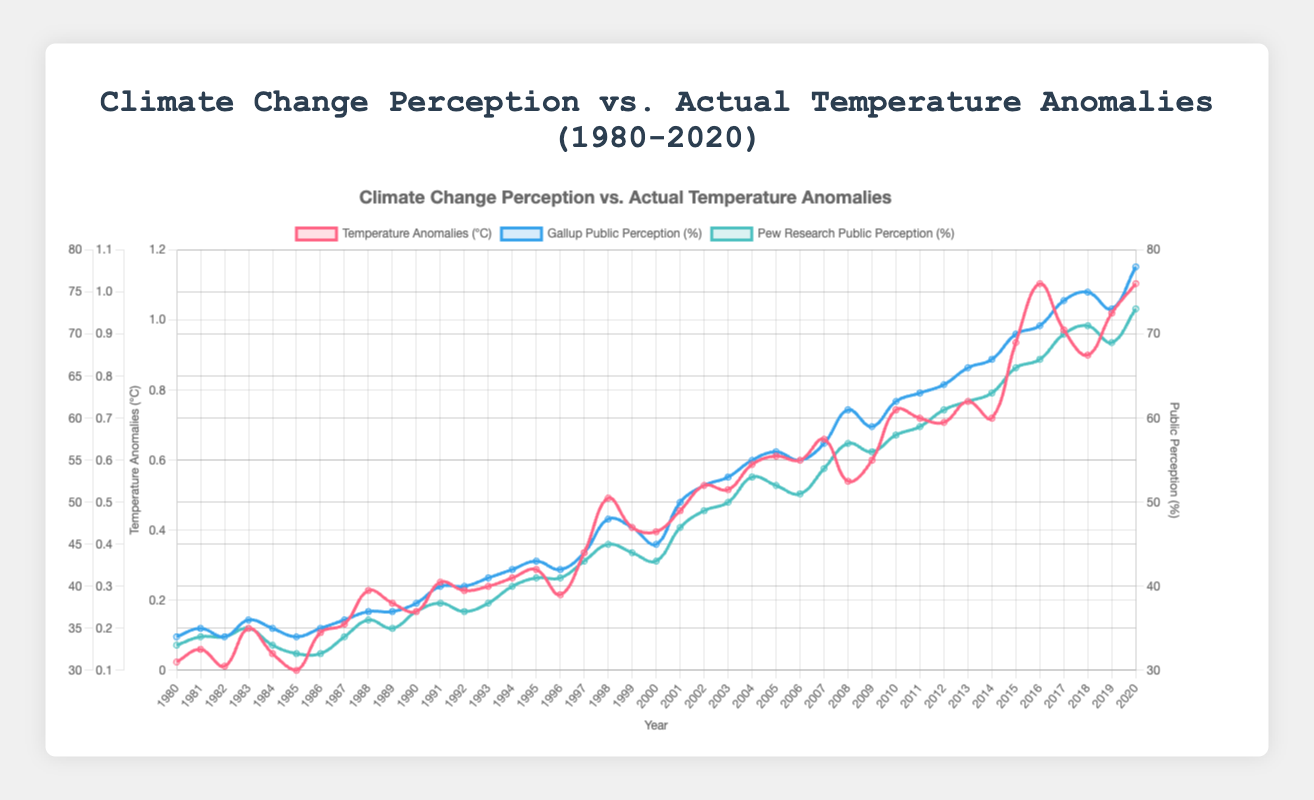Which survey had the higher perception of climate change in 2015? Look at the data points for Gallup and Pew Research in 2015 and compare their values. Gallup has 67%, while Pew Research has 63%.
Answer: Gallup What is the average temperature anomaly for the years 2000 to 2010? Sum the temperature anomaly values from 2000 to 2010 and divide by the number of years. The sum is (0.43 + 0.48 + 0.54 + 0.53 + 0.59 + 0.61 + 0.60 + 0.65 + 0.55 + 0.60 + 0.72), which equals 6.00. Divide by 11 to get the average, 6.00 / 11 = 0.545.
Answer: 0.545 In which year do both Gallup and Pew Research show the same perception percentage? Identify the year where Gallup and Pew Research lines intersect or have the same value. In 1982, both Gallup and Pew Research have a perception value of 34%.
Answer: 1982 By how much did the temperature anomaly change from 1980 to 2020? Find the difference between the temperature anomaly in 2020 and 1980. In 2020, the value is 1.02, and in 1980, it is 0.12. The change is 1.02 - 0.12 = 0.90.
Answer: 0.90 Which year had the highest temperature anomaly? To identify the highest point on the temperature anomaly line, find the year corresponding to the peak value. The highest value is 1.02, occurring in 2016 and 2020.
Answer: 2016 and 2020 What was the Pew Research public perception percentage in 2009, and how did it compare to Gallup for the same year? Look at the Pew Research value for 2009, which is 56%, and compare it to Gallup's value for 2009, which is also 59%.
Answer: Pew Research: 56%, Gallup: 59% How many times did the Gallup public perception of climate change surpass 60%? Count the number of years where the Gallup perception value is greater than 60%. This occurs in 2007, 2010-2020.
Answer: 11 times What is the total increase in Gallup public perception from 1980 to 2020? Subtract the Gallup value in 1980 from the value in 2020. Gallup in 1980 is 34% and in 2020 is 78%. The increase is 78% - 34% = 44%.
Answer: 44% Compare the temperature anomaly trend with the Gallup trend. Are they generally increasing, decreasing, or constant over the decades? Examine the overall direction of both datasets from 1980 to 2020. Both the temperature anomaly and Gallup's perception generally increase over these years.
Answer: Increasing In which year did the temperature anomaly start exceeding 0.5°C, and how does this compare with the public perception trends? Identify the first year the temperature anomaly exceeds 0.5°C, which is 1998. Compare this to Gallup and Pew Research values around that year. Gallup is at 48% and Pew Research at 45% in 1998.
Answer: 1998, Gallup: 48%, Pew Research: 45% 